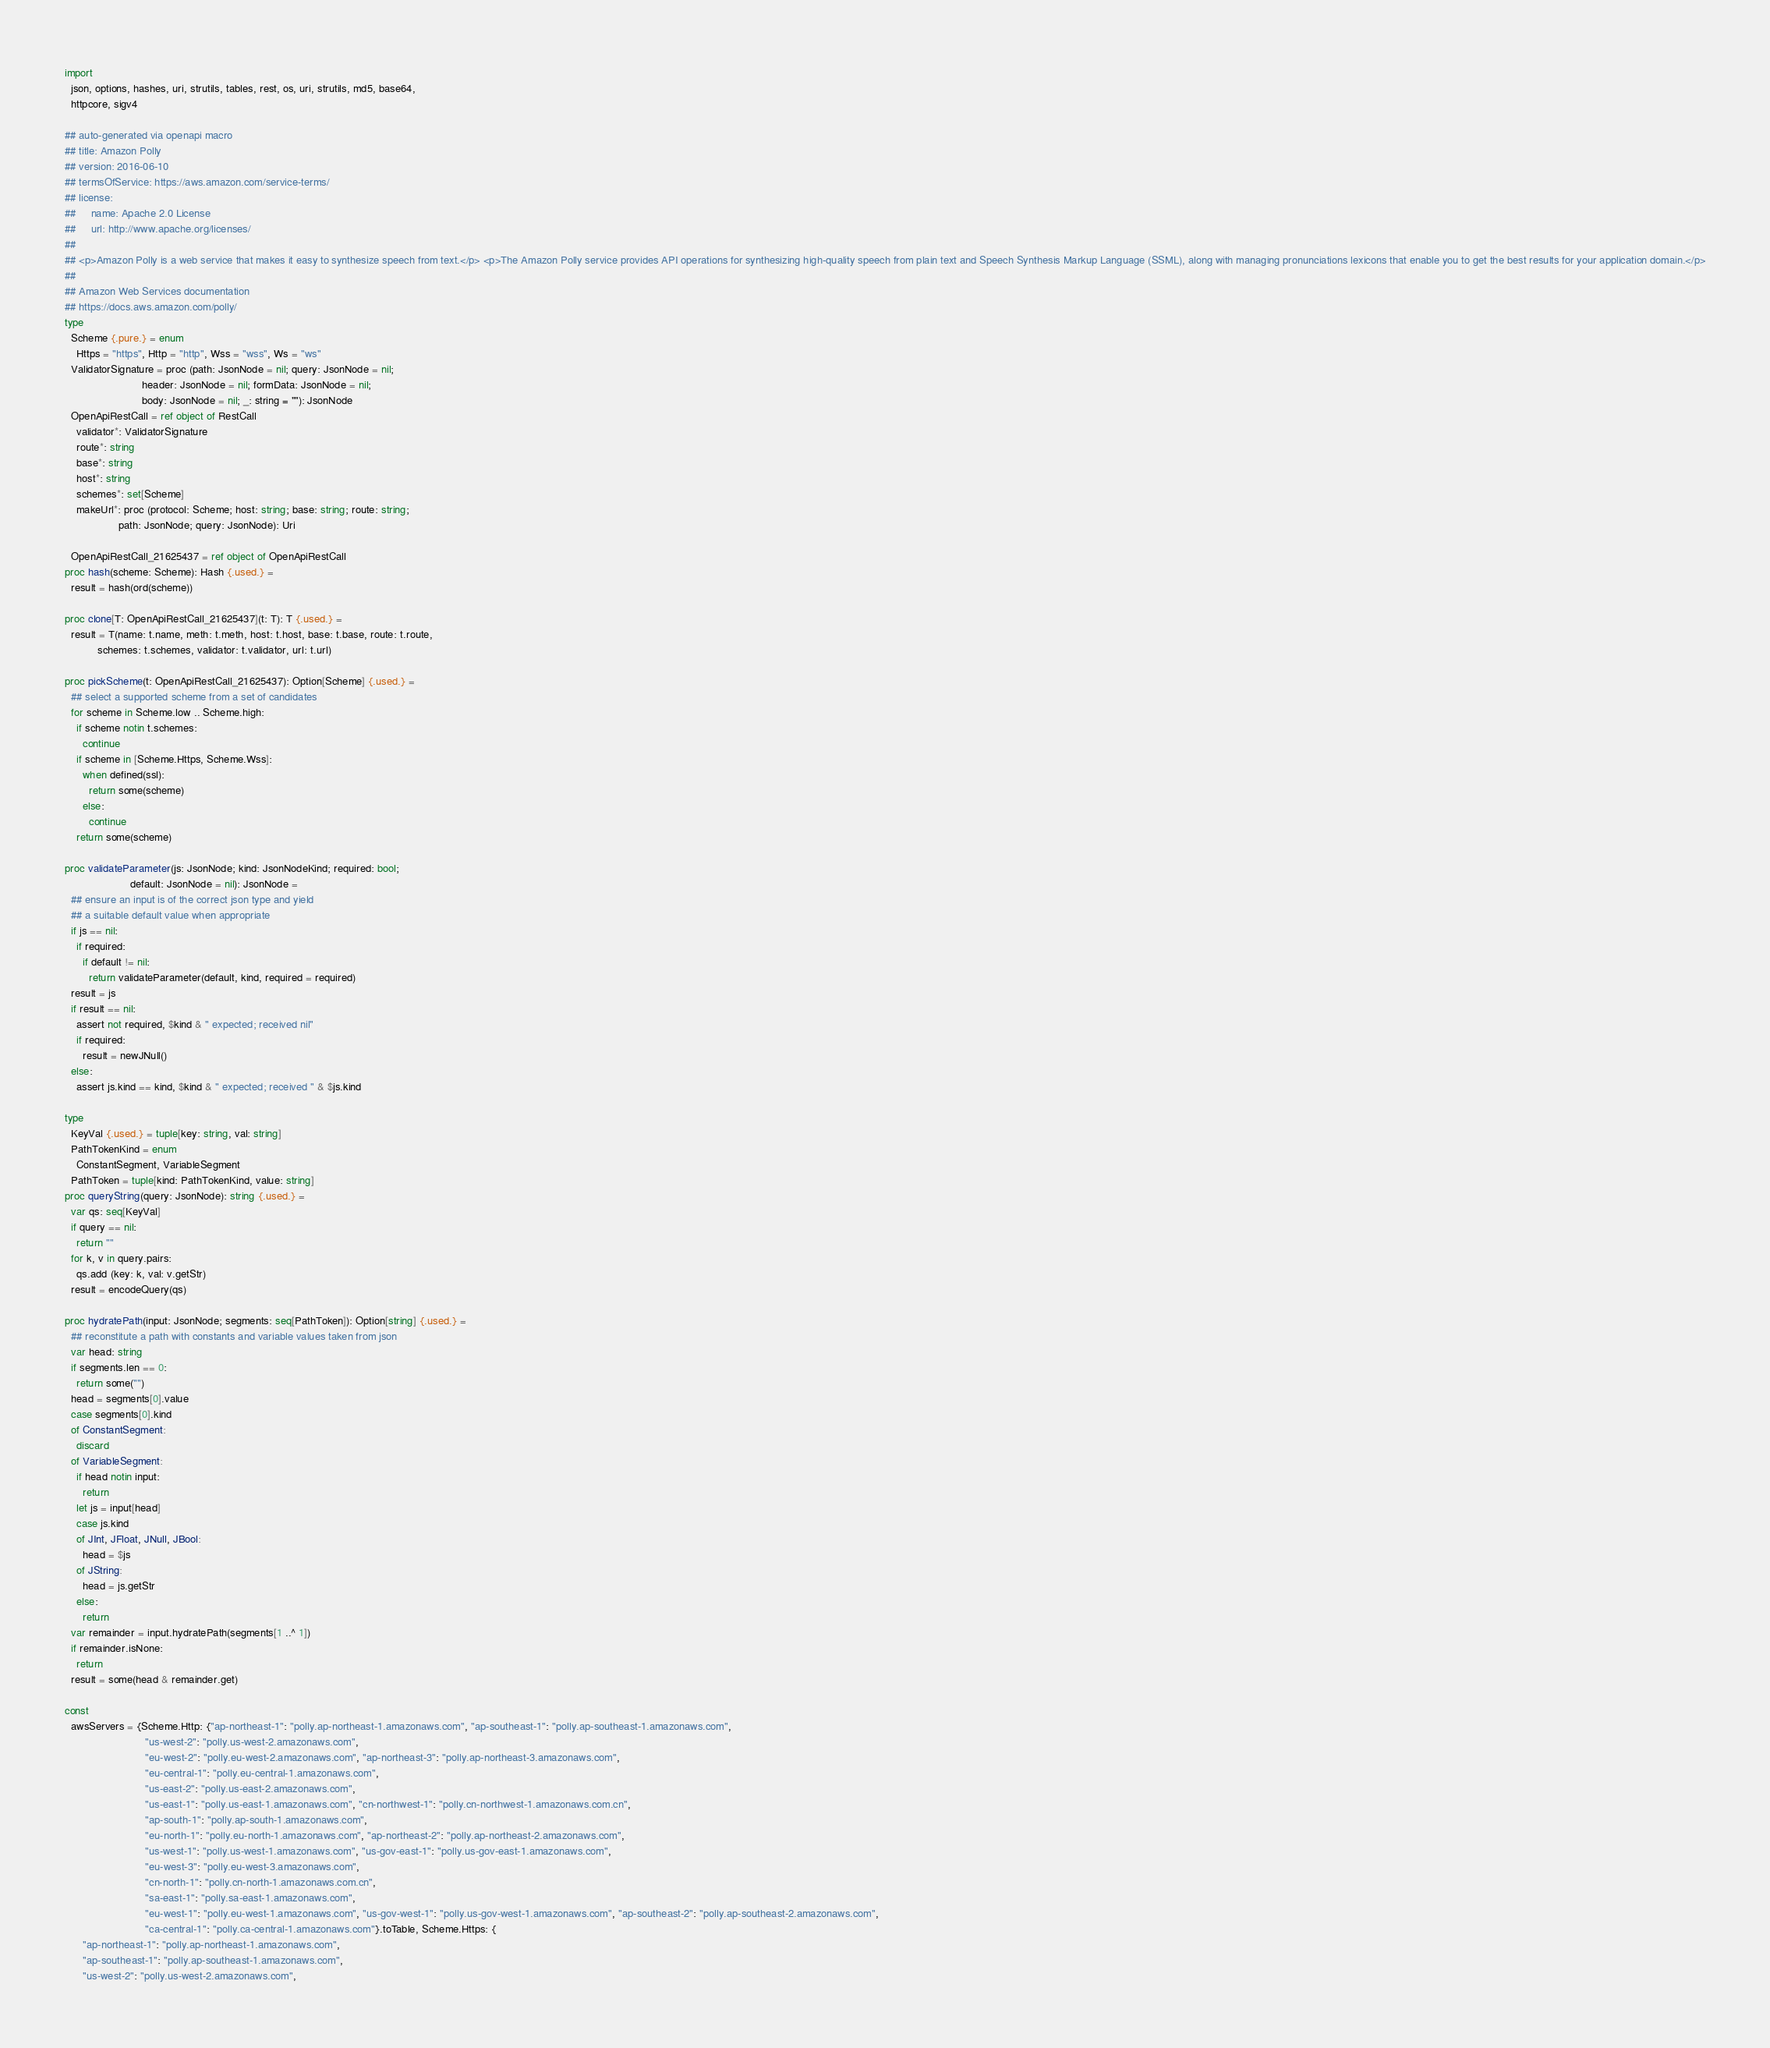Convert code to text. <code><loc_0><loc_0><loc_500><loc_500><_Nim_>
import
  json, options, hashes, uri, strutils, tables, rest, os, uri, strutils, md5, base64,
  httpcore, sigv4

## auto-generated via openapi macro
## title: Amazon Polly
## version: 2016-06-10
## termsOfService: https://aws.amazon.com/service-terms/
## license:
##     name: Apache 2.0 License
##     url: http://www.apache.org/licenses/
## 
## <p>Amazon Polly is a web service that makes it easy to synthesize speech from text.</p> <p>The Amazon Polly service provides API operations for synthesizing high-quality speech from plain text and Speech Synthesis Markup Language (SSML), along with managing pronunciations lexicons that enable you to get the best results for your application domain.</p>
## 
## Amazon Web Services documentation
## https://docs.aws.amazon.com/polly/
type
  Scheme {.pure.} = enum
    Https = "https", Http = "http", Wss = "wss", Ws = "ws"
  ValidatorSignature = proc (path: JsonNode = nil; query: JsonNode = nil;
                          header: JsonNode = nil; formData: JsonNode = nil;
                          body: JsonNode = nil; _: string = ""): JsonNode
  OpenApiRestCall = ref object of RestCall
    validator*: ValidatorSignature
    route*: string
    base*: string
    host*: string
    schemes*: set[Scheme]
    makeUrl*: proc (protocol: Scheme; host: string; base: string; route: string;
                  path: JsonNode; query: JsonNode): Uri

  OpenApiRestCall_21625437 = ref object of OpenApiRestCall
proc hash(scheme: Scheme): Hash {.used.} =
  result = hash(ord(scheme))

proc clone[T: OpenApiRestCall_21625437](t: T): T {.used.} =
  result = T(name: t.name, meth: t.meth, host: t.host, base: t.base, route: t.route,
           schemes: t.schemes, validator: t.validator, url: t.url)

proc pickScheme(t: OpenApiRestCall_21625437): Option[Scheme] {.used.} =
  ## select a supported scheme from a set of candidates
  for scheme in Scheme.low .. Scheme.high:
    if scheme notin t.schemes:
      continue
    if scheme in [Scheme.Https, Scheme.Wss]:
      when defined(ssl):
        return some(scheme)
      else:
        continue
    return some(scheme)

proc validateParameter(js: JsonNode; kind: JsonNodeKind; required: bool;
                      default: JsonNode = nil): JsonNode =
  ## ensure an input is of the correct json type and yield
  ## a suitable default value when appropriate
  if js == nil:
    if required:
      if default != nil:
        return validateParameter(default, kind, required = required)
  result = js
  if result == nil:
    assert not required, $kind & " expected; received nil"
    if required:
      result = newJNull()
  else:
    assert js.kind == kind, $kind & " expected; received " & $js.kind

type
  KeyVal {.used.} = tuple[key: string, val: string]
  PathTokenKind = enum
    ConstantSegment, VariableSegment
  PathToken = tuple[kind: PathTokenKind, value: string]
proc queryString(query: JsonNode): string {.used.} =
  var qs: seq[KeyVal]
  if query == nil:
    return ""
  for k, v in query.pairs:
    qs.add (key: k, val: v.getStr)
  result = encodeQuery(qs)

proc hydratePath(input: JsonNode; segments: seq[PathToken]): Option[string] {.used.} =
  ## reconstitute a path with constants and variable values taken from json
  var head: string
  if segments.len == 0:
    return some("")
  head = segments[0].value
  case segments[0].kind
  of ConstantSegment:
    discard
  of VariableSegment:
    if head notin input:
      return
    let js = input[head]
    case js.kind
    of JInt, JFloat, JNull, JBool:
      head = $js
    of JString:
      head = js.getStr
    else:
      return
  var remainder = input.hydratePath(segments[1 ..^ 1])
  if remainder.isNone:
    return
  result = some(head & remainder.get)

const
  awsServers = {Scheme.Http: {"ap-northeast-1": "polly.ap-northeast-1.amazonaws.com", "ap-southeast-1": "polly.ap-southeast-1.amazonaws.com",
                           "us-west-2": "polly.us-west-2.amazonaws.com",
                           "eu-west-2": "polly.eu-west-2.amazonaws.com", "ap-northeast-3": "polly.ap-northeast-3.amazonaws.com",
                           "eu-central-1": "polly.eu-central-1.amazonaws.com",
                           "us-east-2": "polly.us-east-2.amazonaws.com",
                           "us-east-1": "polly.us-east-1.amazonaws.com", "cn-northwest-1": "polly.cn-northwest-1.amazonaws.com.cn",
                           "ap-south-1": "polly.ap-south-1.amazonaws.com",
                           "eu-north-1": "polly.eu-north-1.amazonaws.com", "ap-northeast-2": "polly.ap-northeast-2.amazonaws.com",
                           "us-west-1": "polly.us-west-1.amazonaws.com", "us-gov-east-1": "polly.us-gov-east-1.amazonaws.com",
                           "eu-west-3": "polly.eu-west-3.amazonaws.com",
                           "cn-north-1": "polly.cn-north-1.amazonaws.com.cn",
                           "sa-east-1": "polly.sa-east-1.amazonaws.com",
                           "eu-west-1": "polly.eu-west-1.amazonaws.com", "us-gov-west-1": "polly.us-gov-west-1.amazonaws.com", "ap-southeast-2": "polly.ap-southeast-2.amazonaws.com",
                           "ca-central-1": "polly.ca-central-1.amazonaws.com"}.toTable, Scheme.Https: {
      "ap-northeast-1": "polly.ap-northeast-1.amazonaws.com",
      "ap-southeast-1": "polly.ap-southeast-1.amazonaws.com",
      "us-west-2": "polly.us-west-2.amazonaws.com",</code> 